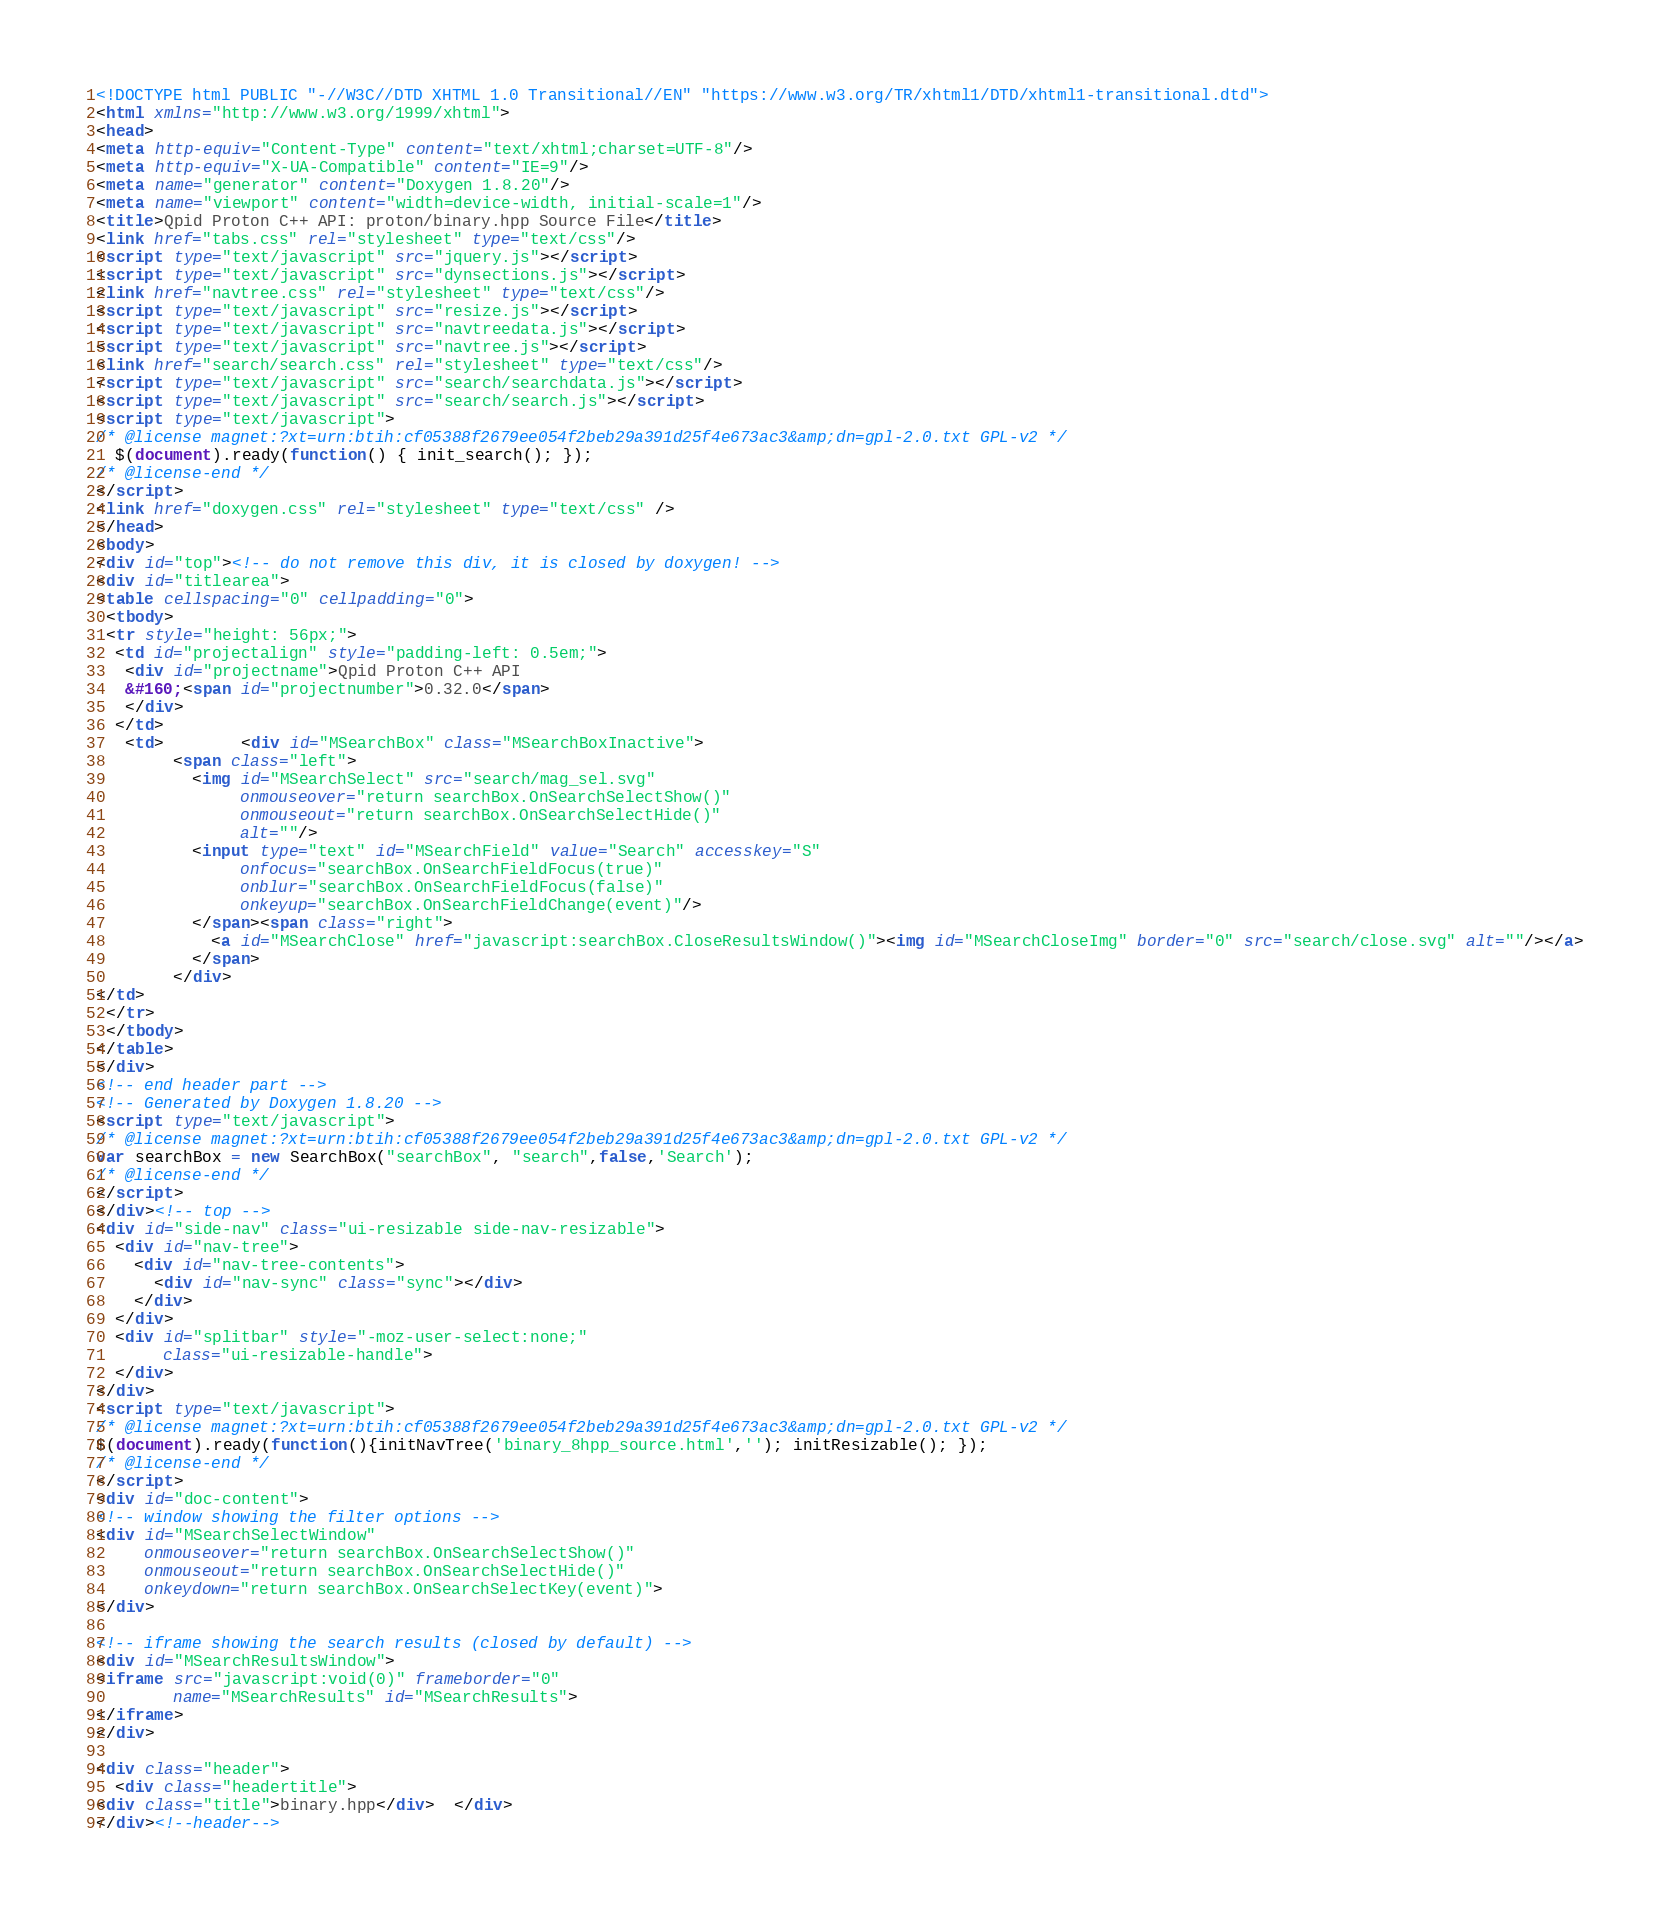<code> <loc_0><loc_0><loc_500><loc_500><_HTML_><!DOCTYPE html PUBLIC "-//W3C//DTD XHTML 1.0 Transitional//EN" "https://www.w3.org/TR/xhtml1/DTD/xhtml1-transitional.dtd">
<html xmlns="http://www.w3.org/1999/xhtml">
<head>
<meta http-equiv="Content-Type" content="text/xhtml;charset=UTF-8"/>
<meta http-equiv="X-UA-Compatible" content="IE=9"/>
<meta name="generator" content="Doxygen 1.8.20"/>
<meta name="viewport" content="width=device-width, initial-scale=1"/>
<title>Qpid Proton C++ API: proton/binary.hpp Source File</title>
<link href="tabs.css" rel="stylesheet" type="text/css"/>
<script type="text/javascript" src="jquery.js"></script>
<script type="text/javascript" src="dynsections.js"></script>
<link href="navtree.css" rel="stylesheet" type="text/css"/>
<script type="text/javascript" src="resize.js"></script>
<script type="text/javascript" src="navtreedata.js"></script>
<script type="text/javascript" src="navtree.js"></script>
<link href="search/search.css" rel="stylesheet" type="text/css"/>
<script type="text/javascript" src="search/searchdata.js"></script>
<script type="text/javascript" src="search/search.js"></script>
<script type="text/javascript">
/* @license magnet:?xt=urn:btih:cf05388f2679ee054f2beb29a391d25f4e673ac3&amp;dn=gpl-2.0.txt GPL-v2 */
  $(document).ready(function() { init_search(); });
/* @license-end */
</script>
<link href="doxygen.css" rel="stylesheet" type="text/css" />
</head>
<body>
<div id="top"><!-- do not remove this div, it is closed by doxygen! -->
<div id="titlearea">
<table cellspacing="0" cellpadding="0">
 <tbody>
 <tr style="height: 56px;">
  <td id="projectalign" style="padding-left: 0.5em;">
   <div id="projectname">Qpid Proton C++ API
   &#160;<span id="projectnumber">0.32.0</span>
   </div>
  </td>
   <td>        <div id="MSearchBox" class="MSearchBoxInactive">
        <span class="left">
          <img id="MSearchSelect" src="search/mag_sel.svg"
               onmouseover="return searchBox.OnSearchSelectShow()"
               onmouseout="return searchBox.OnSearchSelectHide()"
               alt=""/>
          <input type="text" id="MSearchField" value="Search" accesskey="S"
               onfocus="searchBox.OnSearchFieldFocus(true)" 
               onblur="searchBox.OnSearchFieldFocus(false)" 
               onkeyup="searchBox.OnSearchFieldChange(event)"/>
          </span><span class="right">
            <a id="MSearchClose" href="javascript:searchBox.CloseResultsWindow()"><img id="MSearchCloseImg" border="0" src="search/close.svg" alt=""/></a>
          </span>
        </div>
</td>
 </tr>
 </tbody>
</table>
</div>
<!-- end header part -->
<!-- Generated by Doxygen 1.8.20 -->
<script type="text/javascript">
/* @license magnet:?xt=urn:btih:cf05388f2679ee054f2beb29a391d25f4e673ac3&amp;dn=gpl-2.0.txt GPL-v2 */
var searchBox = new SearchBox("searchBox", "search",false,'Search');
/* @license-end */
</script>
</div><!-- top -->
<div id="side-nav" class="ui-resizable side-nav-resizable">
  <div id="nav-tree">
    <div id="nav-tree-contents">
      <div id="nav-sync" class="sync"></div>
    </div>
  </div>
  <div id="splitbar" style="-moz-user-select:none;" 
       class="ui-resizable-handle">
  </div>
</div>
<script type="text/javascript">
/* @license magnet:?xt=urn:btih:cf05388f2679ee054f2beb29a391d25f4e673ac3&amp;dn=gpl-2.0.txt GPL-v2 */
$(document).ready(function(){initNavTree('binary_8hpp_source.html',''); initResizable(); });
/* @license-end */
</script>
<div id="doc-content">
<!-- window showing the filter options -->
<div id="MSearchSelectWindow"
     onmouseover="return searchBox.OnSearchSelectShow()"
     onmouseout="return searchBox.OnSearchSelectHide()"
     onkeydown="return searchBox.OnSearchSelectKey(event)">
</div>

<!-- iframe showing the search results (closed by default) -->
<div id="MSearchResultsWindow">
<iframe src="javascript:void(0)" frameborder="0" 
        name="MSearchResults" id="MSearchResults">
</iframe>
</div>

<div class="header">
  <div class="headertitle">
<div class="title">binary.hpp</div>  </div>
</div><!--header--></code> 